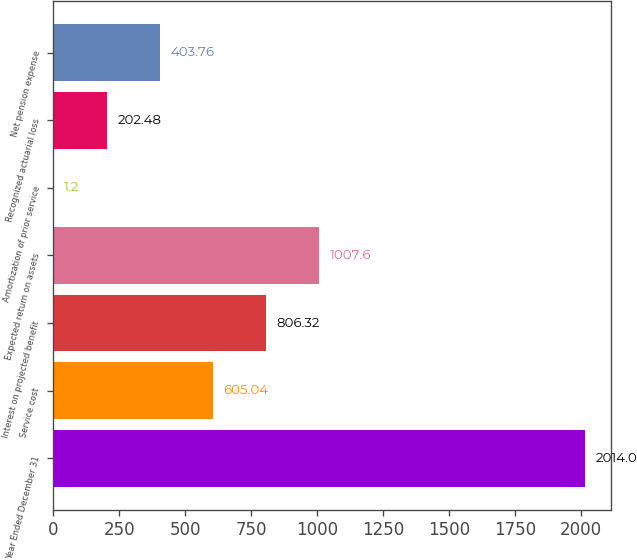Convert chart. <chart><loc_0><loc_0><loc_500><loc_500><bar_chart><fcel>Year Ended December 31<fcel>Service cost<fcel>Interest on projected benefit<fcel>Expected return on assets<fcel>Amortization of prior service<fcel>Recognized actuarial loss<fcel>Net pension expense<nl><fcel>2014<fcel>605.04<fcel>806.32<fcel>1007.6<fcel>1.2<fcel>202.48<fcel>403.76<nl></chart> 